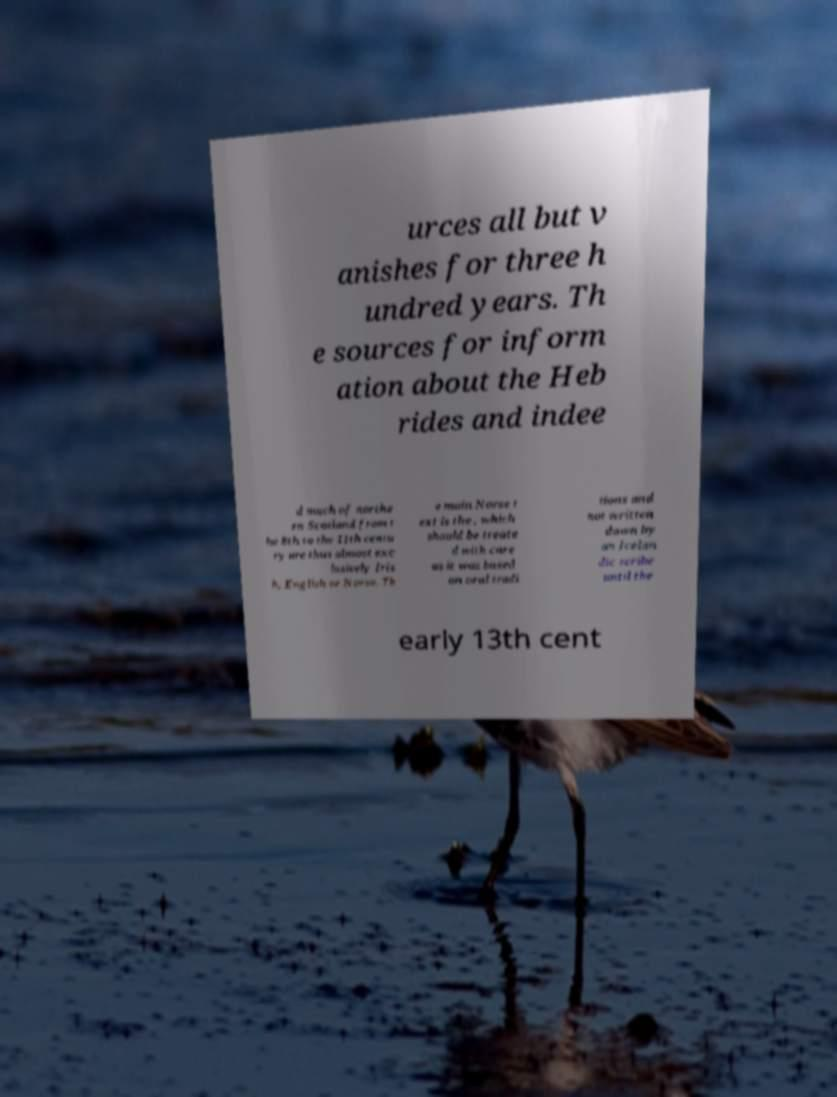Could you extract and type out the text from this image? urces all but v anishes for three h undred years. Th e sources for inform ation about the Heb rides and indee d much of northe rn Scotland from t he 8th to the 11th centu ry are thus almost exc lusively Iris h, English or Norse. Th e main Norse t ext is the , which should be treate d with care as it was based on oral tradi tions and not written down by an Icelan dic scribe until the early 13th cent 